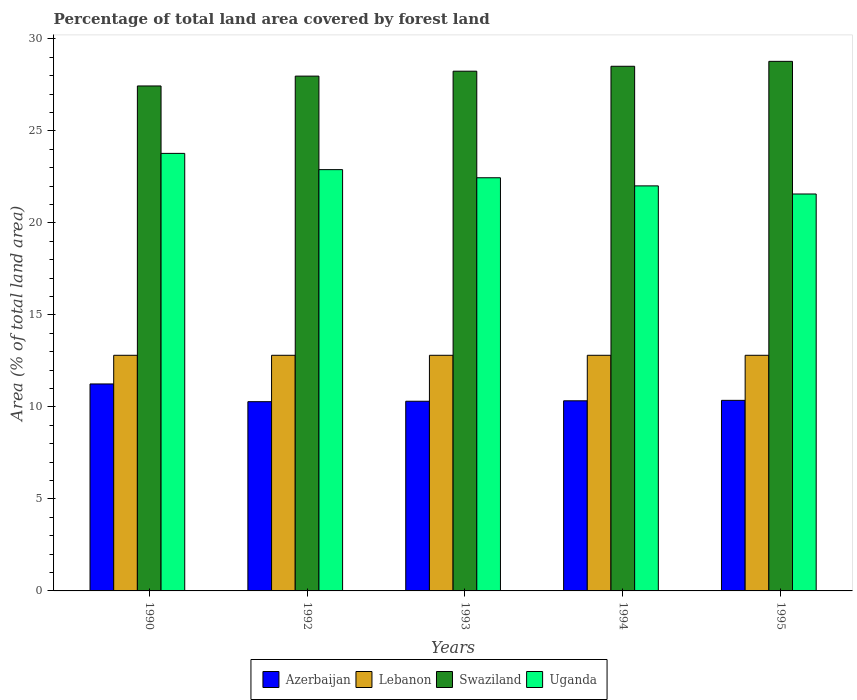Are the number of bars on each tick of the X-axis equal?
Offer a terse response. Yes. How many bars are there on the 2nd tick from the left?
Offer a terse response. 4. How many bars are there on the 2nd tick from the right?
Offer a terse response. 4. In how many cases, is the number of bars for a given year not equal to the number of legend labels?
Your answer should be very brief. 0. What is the percentage of forest land in Azerbaijan in 1993?
Offer a very short reply. 10.31. Across all years, what is the maximum percentage of forest land in Azerbaijan?
Ensure brevity in your answer.  11.25. Across all years, what is the minimum percentage of forest land in Azerbaijan?
Your answer should be very brief. 10.28. In which year was the percentage of forest land in Lebanon maximum?
Give a very brief answer. 1990. What is the total percentage of forest land in Azerbaijan in the graph?
Offer a terse response. 52.53. What is the difference between the percentage of forest land in Lebanon in 1994 and that in 1995?
Make the answer very short. 0. What is the difference between the percentage of forest land in Swaziland in 1992 and the percentage of forest land in Azerbaijan in 1995?
Your answer should be very brief. 17.62. What is the average percentage of forest land in Uganda per year?
Provide a short and direct response. 22.54. In the year 1993, what is the difference between the percentage of forest land in Uganda and percentage of forest land in Swaziland?
Offer a terse response. -5.79. What is the ratio of the percentage of forest land in Lebanon in 1992 to that in 1994?
Your response must be concise. 1. Is the difference between the percentage of forest land in Uganda in 1990 and 1993 greater than the difference between the percentage of forest land in Swaziland in 1990 and 1993?
Keep it short and to the point. Yes. What is the difference between the highest and the lowest percentage of forest land in Azerbaijan?
Provide a succinct answer. 0.96. Is the sum of the percentage of forest land in Uganda in 1990 and 1995 greater than the maximum percentage of forest land in Lebanon across all years?
Make the answer very short. Yes. What does the 2nd bar from the left in 1994 represents?
Provide a short and direct response. Lebanon. What does the 1st bar from the right in 1990 represents?
Provide a short and direct response. Uganda. How many bars are there?
Your answer should be very brief. 20. Are all the bars in the graph horizontal?
Offer a very short reply. No. How many legend labels are there?
Ensure brevity in your answer.  4. What is the title of the graph?
Ensure brevity in your answer.  Percentage of total land area covered by forest land. Does "Central Europe" appear as one of the legend labels in the graph?
Your answer should be compact. No. What is the label or title of the Y-axis?
Your answer should be compact. Area (% of total land area). What is the Area (% of total land area) in Azerbaijan in 1990?
Offer a terse response. 11.25. What is the Area (% of total land area) in Lebanon in 1990?
Keep it short and to the point. 12.81. What is the Area (% of total land area) in Swaziland in 1990?
Provide a short and direct response. 27.44. What is the Area (% of total land area) in Uganda in 1990?
Your answer should be compact. 23.78. What is the Area (% of total land area) in Azerbaijan in 1992?
Offer a terse response. 10.28. What is the Area (% of total land area) in Lebanon in 1992?
Provide a short and direct response. 12.81. What is the Area (% of total land area) of Swaziland in 1992?
Ensure brevity in your answer.  27.98. What is the Area (% of total land area) of Uganda in 1992?
Keep it short and to the point. 22.89. What is the Area (% of total land area) in Azerbaijan in 1993?
Provide a succinct answer. 10.31. What is the Area (% of total land area) in Lebanon in 1993?
Keep it short and to the point. 12.81. What is the Area (% of total land area) in Swaziland in 1993?
Give a very brief answer. 28.24. What is the Area (% of total land area) in Uganda in 1993?
Offer a very short reply. 22.45. What is the Area (% of total land area) of Azerbaijan in 1994?
Ensure brevity in your answer.  10.33. What is the Area (% of total land area) of Lebanon in 1994?
Your answer should be compact. 12.81. What is the Area (% of total land area) in Swaziland in 1994?
Provide a short and direct response. 28.51. What is the Area (% of total land area) in Uganda in 1994?
Give a very brief answer. 22.01. What is the Area (% of total land area) in Azerbaijan in 1995?
Offer a terse response. 10.36. What is the Area (% of total land area) in Lebanon in 1995?
Provide a succinct answer. 12.81. What is the Area (% of total land area) in Swaziland in 1995?
Offer a terse response. 28.78. What is the Area (% of total land area) in Uganda in 1995?
Give a very brief answer. 21.57. Across all years, what is the maximum Area (% of total land area) in Azerbaijan?
Keep it short and to the point. 11.25. Across all years, what is the maximum Area (% of total land area) of Lebanon?
Your response must be concise. 12.81. Across all years, what is the maximum Area (% of total land area) of Swaziland?
Provide a short and direct response. 28.78. Across all years, what is the maximum Area (% of total land area) of Uganda?
Keep it short and to the point. 23.78. Across all years, what is the minimum Area (% of total land area) of Azerbaijan?
Offer a terse response. 10.28. Across all years, what is the minimum Area (% of total land area) of Lebanon?
Your response must be concise. 12.81. Across all years, what is the minimum Area (% of total land area) of Swaziland?
Provide a succinct answer. 27.44. Across all years, what is the minimum Area (% of total land area) of Uganda?
Your answer should be compact. 21.57. What is the total Area (% of total land area) in Azerbaijan in the graph?
Your answer should be compact. 52.53. What is the total Area (% of total land area) of Lebanon in the graph?
Give a very brief answer. 64.03. What is the total Area (% of total land area) of Swaziland in the graph?
Keep it short and to the point. 140.95. What is the total Area (% of total land area) in Uganda in the graph?
Give a very brief answer. 112.71. What is the difference between the Area (% of total land area) in Azerbaijan in 1990 and that in 1992?
Offer a very short reply. 0.96. What is the difference between the Area (% of total land area) of Swaziland in 1990 and that in 1992?
Offer a terse response. -0.53. What is the difference between the Area (% of total land area) of Uganda in 1990 and that in 1992?
Provide a short and direct response. 0.88. What is the difference between the Area (% of total land area) of Azerbaijan in 1990 and that in 1993?
Ensure brevity in your answer.  0.94. What is the difference between the Area (% of total land area) in Lebanon in 1990 and that in 1993?
Offer a very short reply. 0. What is the difference between the Area (% of total land area) in Swaziland in 1990 and that in 1993?
Your answer should be compact. -0.8. What is the difference between the Area (% of total land area) of Uganda in 1990 and that in 1993?
Your answer should be very brief. 1.32. What is the difference between the Area (% of total land area) in Azerbaijan in 1990 and that in 1994?
Give a very brief answer. 0.92. What is the difference between the Area (% of total land area) in Swaziland in 1990 and that in 1994?
Your answer should be very brief. -1.07. What is the difference between the Area (% of total land area) in Uganda in 1990 and that in 1994?
Keep it short and to the point. 1.77. What is the difference between the Area (% of total land area) of Azerbaijan in 1990 and that in 1995?
Provide a succinct answer. 0.89. What is the difference between the Area (% of total land area) of Swaziland in 1990 and that in 1995?
Your answer should be compact. -1.34. What is the difference between the Area (% of total land area) of Uganda in 1990 and that in 1995?
Your answer should be compact. 2.21. What is the difference between the Area (% of total land area) in Azerbaijan in 1992 and that in 1993?
Give a very brief answer. -0.02. What is the difference between the Area (% of total land area) of Swaziland in 1992 and that in 1993?
Your response must be concise. -0.27. What is the difference between the Area (% of total land area) of Uganda in 1992 and that in 1993?
Offer a very short reply. 0.44. What is the difference between the Area (% of total land area) in Azerbaijan in 1992 and that in 1994?
Make the answer very short. -0.05. What is the difference between the Area (% of total land area) in Lebanon in 1992 and that in 1994?
Your answer should be very brief. 0. What is the difference between the Area (% of total land area) in Swaziland in 1992 and that in 1994?
Provide a short and direct response. -0.53. What is the difference between the Area (% of total land area) in Uganda in 1992 and that in 1994?
Offer a terse response. 0.88. What is the difference between the Area (% of total land area) of Azerbaijan in 1992 and that in 1995?
Provide a succinct answer. -0.07. What is the difference between the Area (% of total land area) of Swaziland in 1992 and that in 1995?
Ensure brevity in your answer.  -0.8. What is the difference between the Area (% of total land area) of Uganda in 1992 and that in 1995?
Provide a succinct answer. 1.32. What is the difference between the Area (% of total land area) in Azerbaijan in 1993 and that in 1994?
Keep it short and to the point. -0.02. What is the difference between the Area (% of total land area) of Swaziland in 1993 and that in 1994?
Make the answer very short. -0.27. What is the difference between the Area (% of total land area) in Uganda in 1993 and that in 1994?
Your answer should be compact. 0.44. What is the difference between the Area (% of total land area) of Azerbaijan in 1993 and that in 1995?
Provide a succinct answer. -0.05. What is the difference between the Area (% of total land area) of Lebanon in 1993 and that in 1995?
Your response must be concise. 0. What is the difference between the Area (% of total land area) of Swaziland in 1993 and that in 1995?
Offer a terse response. -0.53. What is the difference between the Area (% of total land area) of Uganda in 1993 and that in 1995?
Ensure brevity in your answer.  0.88. What is the difference between the Area (% of total land area) in Azerbaijan in 1994 and that in 1995?
Offer a very short reply. -0.02. What is the difference between the Area (% of total land area) of Swaziland in 1994 and that in 1995?
Offer a very short reply. -0.27. What is the difference between the Area (% of total land area) in Uganda in 1994 and that in 1995?
Make the answer very short. 0.44. What is the difference between the Area (% of total land area) in Azerbaijan in 1990 and the Area (% of total land area) in Lebanon in 1992?
Give a very brief answer. -1.56. What is the difference between the Area (% of total land area) of Azerbaijan in 1990 and the Area (% of total land area) of Swaziland in 1992?
Ensure brevity in your answer.  -16.73. What is the difference between the Area (% of total land area) in Azerbaijan in 1990 and the Area (% of total land area) in Uganda in 1992?
Offer a very short reply. -11.65. What is the difference between the Area (% of total land area) in Lebanon in 1990 and the Area (% of total land area) in Swaziland in 1992?
Provide a short and direct response. -15.17. What is the difference between the Area (% of total land area) of Lebanon in 1990 and the Area (% of total land area) of Uganda in 1992?
Offer a very short reply. -10.09. What is the difference between the Area (% of total land area) of Swaziland in 1990 and the Area (% of total land area) of Uganda in 1992?
Make the answer very short. 4.55. What is the difference between the Area (% of total land area) in Azerbaijan in 1990 and the Area (% of total land area) in Lebanon in 1993?
Make the answer very short. -1.56. What is the difference between the Area (% of total land area) in Azerbaijan in 1990 and the Area (% of total land area) in Swaziland in 1993?
Your answer should be very brief. -17. What is the difference between the Area (% of total land area) in Azerbaijan in 1990 and the Area (% of total land area) in Uganda in 1993?
Offer a very short reply. -11.21. What is the difference between the Area (% of total land area) of Lebanon in 1990 and the Area (% of total land area) of Swaziland in 1993?
Offer a very short reply. -15.44. What is the difference between the Area (% of total land area) in Lebanon in 1990 and the Area (% of total land area) in Uganda in 1993?
Offer a very short reply. -9.65. What is the difference between the Area (% of total land area) of Swaziland in 1990 and the Area (% of total land area) of Uganda in 1993?
Give a very brief answer. 4.99. What is the difference between the Area (% of total land area) in Azerbaijan in 1990 and the Area (% of total land area) in Lebanon in 1994?
Make the answer very short. -1.56. What is the difference between the Area (% of total land area) in Azerbaijan in 1990 and the Area (% of total land area) in Swaziland in 1994?
Ensure brevity in your answer.  -17.26. What is the difference between the Area (% of total land area) of Azerbaijan in 1990 and the Area (% of total land area) of Uganda in 1994?
Offer a very short reply. -10.76. What is the difference between the Area (% of total land area) of Lebanon in 1990 and the Area (% of total land area) of Swaziland in 1994?
Your answer should be very brief. -15.71. What is the difference between the Area (% of total land area) of Lebanon in 1990 and the Area (% of total land area) of Uganda in 1994?
Offer a terse response. -9.21. What is the difference between the Area (% of total land area) in Swaziland in 1990 and the Area (% of total land area) in Uganda in 1994?
Provide a short and direct response. 5.43. What is the difference between the Area (% of total land area) of Azerbaijan in 1990 and the Area (% of total land area) of Lebanon in 1995?
Offer a terse response. -1.56. What is the difference between the Area (% of total land area) of Azerbaijan in 1990 and the Area (% of total land area) of Swaziland in 1995?
Give a very brief answer. -17.53. What is the difference between the Area (% of total land area) of Azerbaijan in 1990 and the Area (% of total land area) of Uganda in 1995?
Offer a very short reply. -10.32. What is the difference between the Area (% of total land area) of Lebanon in 1990 and the Area (% of total land area) of Swaziland in 1995?
Give a very brief answer. -15.97. What is the difference between the Area (% of total land area) of Lebanon in 1990 and the Area (% of total land area) of Uganda in 1995?
Give a very brief answer. -8.77. What is the difference between the Area (% of total land area) of Swaziland in 1990 and the Area (% of total land area) of Uganda in 1995?
Give a very brief answer. 5.87. What is the difference between the Area (% of total land area) in Azerbaijan in 1992 and the Area (% of total land area) in Lebanon in 1993?
Make the answer very short. -2.52. What is the difference between the Area (% of total land area) of Azerbaijan in 1992 and the Area (% of total land area) of Swaziland in 1993?
Offer a terse response. -17.96. What is the difference between the Area (% of total land area) in Azerbaijan in 1992 and the Area (% of total land area) in Uganda in 1993?
Provide a succinct answer. -12.17. What is the difference between the Area (% of total land area) in Lebanon in 1992 and the Area (% of total land area) in Swaziland in 1993?
Your answer should be compact. -15.44. What is the difference between the Area (% of total land area) in Lebanon in 1992 and the Area (% of total land area) in Uganda in 1993?
Offer a terse response. -9.65. What is the difference between the Area (% of total land area) of Swaziland in 1992 and the Area (% of total land area) of Uganda in 1993?
Make the answer very short. 5.52. What is the difference between the Area (% of total land area) in Azerbaijan in 1992 and the Area (% of total land area) in Lebanon in 1994?
Give a very brief answer. -2.52. What is the difference between the Area (% of total land area) in Azerbaijan in 1992 and the Area (% of total land area) in Swaziland in 1994?
Offer a terse response. -18.23. What is the difference between the Area (% of total land area) of Azerbaijan in 1992 and the Area (% of total land area) of Uganda in 1994?
Provide a short and direct response. -11.73. What is the difference between the Area (% of total land area) of Lebanon in 1992 and the Area (% of total land area) of Swaziland in 1994?
Give a very brief answer. -15.71. What is the difference between the Area (% of total land area) in Lebanon in 1992 and the Area (% of total land area) in Uganda in 1994?
Ensure brevity in your answer.  -9.21. What is the difference between the Area (% of total land area) in Swaziland in 1992 and the Area (% of total land area) in Uganda in 1994?
Give a very brief answer. 5.96. What is the difference between the Area (% of total land area) in Azerbaijan in 1992 and the Area (% of total land area) in Lebanon in 1995?
Give a very brief answer. -2.52. What is the difference between the Area (% of total land area) of Azerbaijan in 1992 and the Area (% of total land area) of Swaziland in 1995?
Your response must be concise. -18.5. What is the difference between the Area (% of total land area) in Azerbaijan in 1992 and the Area (% of total land area) in Uganda in 1995?
Offer a very short reply. -11.29. What is the difference between the Area (% of total land area) of Lebanon in 1992 and the Area (% of total land area) of Swaziland in 1995?
Give a very brief answer. -15.97. What is the difference between the Area (% of total land area) of Lebanon in 1992 and the Area (% of total land area) of Uganda in 1995?
Make the answer very short. -8.77. What is the difference between the Area (% of total land area) in Swaziland in 1992 and the Area (% of total land area) in Uganda in 1995?
Make the answer very short. 6.41. What is the difference between the Area (% of total land area) in Azerbaijan in 1993 and the Area (% of total land area) in Lebanon in 1994?
Make the answer very short. -2.5. What is the difference between the Area (% of total land area) in Azerbaijan in 1993 and the Area (% of total land area) in Swaziland in 1994?
Your answer should be very brief. -18.2. What is the difference between the Area (% of total land area) in Azerbaijan in 1993 and the Area (% of total land area) in Uganda in 1994?
Keep it short and to the point. -11.7. What is the difference between the Area (% of total land area) of Lebanon in 1993 and the Area (% of total land area) of Swaziland in 1994?
Your answer should be compact. -15.71. What is the difference between the Area (% of total land area) of Lebanon in 1993 and the Area (% of total land area) of Uganda in 1994?
Your answer should be very brief. -9.21. What is the difference between the Area (% of total land area) of Swaziland in 1993 and the Area (% of total land area) of Uganda in 1994?
Your response must be concise. 6.23. What is the difference between the Area (% of total land area) in Azerbaijan in 1993 and the Area (% of total land area) in Lebanon in 1995?
Give a very brief answer. -2.5. What is the difference between the Area (% of total land area) in Azerbaijan in 1993 and the Area (% of total land area) in Swaziland in 1995?
Ensure brevity in your answer.  -18.47. What is the difference between the Area (% of total land area) in Azerbaijan in 1993 and the Area (% of total land area) in Uganda in 1995?
Your response must be concise. -11.26. What is the difference between the Area (% of total land area) of Lebanon in 1993 and the Area (% of total land area) of Swaziland in 1995?
Keep it short and to the point. -15.97. What is the difference between the Area (% of total land area) of Lebanon in 1993 and the Area (% of total land area) of Uganda in 1995?
Offer a very short reply. -8.77. What is the difference between the Area (% of total land area) of Swaziland in 1993 and the Area (% of total land area) of Uganda in 1995?
Give a very brief answer. 6.67. What is the difference between the Area (% of total land area) of Azerbaijan in 1994 and the Area (% of total land area) of Lebanon in 1995?
Provide a succinct answer. -2.47. What is the difference between the Area (% of total land area) of Azerbaijan in 1994 and the Area (% of total land area) of Swaziland in 1995?
Provide a succinct answer. -18.45. What is the difference between the Area (% of total land area) of Azerbaijan in 1994 and the Area (% of total land area) of Uganda in 1995?
Give a very brief answer. -11.24. What is the difference between the Area (% of total land area) in Lebanon in 1994 and the Area (% of total land area) in Swaziland in 1995?
Offer a very short reply. -15.97. What is the difference between the Area (% of total land area) in Lebanon in 1994 and the Area (% of total land area) in Uganda in 1995?
Ensure brevity in your answer.  -8.77. What is the difference between the Area (% of total land area) in Swaziland in 1994 and the Area (% of total land area) in Uganda in 1995?
Offer a terse response. 6.94. What is the average Area (% of total land area) in Azerbaijan per year?
Offer a terse response. 10.51. What is the average Area (% of total land area) in Lebanon per year?
Keep it short and to the point. 12.81. What is the average Area (% of total land area) in Swaziland per year?
Keep it short and to the point. 28.19. What is the average Area (% of total land area) of Uganda per year?
Your answer should be very brief. 22.54. In the year 1990, what is the difference between the Area (% of total land area) of Azerbaijan and Area (% of total land area) of Lebanon?
Offer a terse response. -1.56. In the year 1990, what is the difference between the Area (% of total land area) in Azerbaijan and Area (% of total land area) in Swaziland?
Provide a succinct answer. -16.19. In the year 1990, what is the difference between the Area (% of total land area) in Azerbaijan and Area (% of total land area) in Uganda?
Provide a succinct answer. -12.53. In the year 1990, what is the difference between the Area (% of total land area) of Lebanon and Area (% of total land area) of Swaziland?
Your answer should be very brief. -14.64. In the year 1990, what is the difference between the Area (% of total land area) in Lebanon and Area (% of total land area) in Uganda?
Your response must be concise. -10.97. In the year 1990, what is the difference between the Area (% of total land area) in Swaziland and Area (% of total land area) in Uganda?
Your response must be concise. 3.66. In the year 1992, what is the difference between the Area (% of total land area) of Azerbaijan and Area (% of total land area) of Lebanon?
Offer a terse response. -2.52. In the year 1992, what is the difference between the Area (% of total land area) of Azerbaijan and Area (% of total land area) of Swaziland?
Provide a succinct answer. -17.69. In the year 1992, what is the difference between the Area (% of total land area) in Azerbaijan and Area (% of total land area) in Uganda?
Your answer should be compact. -12.61. In the year 1992, what is the difference between the Area (% of total land area) in Lebanon and Area (% of total land area) in Swaziland?
Provide a succinct answer. -15.17. In the year 1992, what is the difference between the Area (% of total land area) of Lebanon and Area (% of total land area) of Uganda?
Give a very brief answer. -10.09. In the year 1992, what is the difference between the Area (% of total land area) of Swaziland and Area (% of total land area) of Uganda?
Provide a succinct answer. 5.08. In the year 1993, what is the difference between the Area (% of total land area) in Azerbaijan and Area (% of total land area) in Lebanon?
Provide a short and direct response. -2.5. In the year 1993, what is the difference between the Area (% of total land area) of Azerbaijan and Area (% of total land area) of Swaziland?
Your response must be concise. -17.94. In the year 1993, what is the difference between the Area (% of total land area) of Azerbaijan and Area (% of total land area) of Uganda?
Ensure brevity in your answer.  -12.15. In the year 1993, what is the difference between the Area (% of total land area) of Lebanon and Area (% of total land area) of Swaziland?
Offer a very short reply. -15.44. In the year 1993, what is the difference between the Area (% of total land area) in Lebanon and Area (% of total land area) in Uganda?
Your response must be concise. -9.65. In the year 1993, what is the difference between the Area (% of total land area) of Swaziland and Area (% of total land area) of Uganda?
Give a very brief answer. 5.79. In the year 1994, what is the difference between the Area (% of total land area) in Azerbaijan and Area (% of total land area) in Lebanon?
Your answer should be very brief. -2.47. In the year 1994, what is the difference between the Area (% of total land area) of Azerbaijan and Area (% of total land area) of Swaziland?
Ensure brevity in your answer.  -18.18. In the year 1994, what is the difference between the Area (% of total land area) in Azerbaijan and Area (% of total land area) in Uganda?
Keep it short and to the point. -11.68. In the year 1994, what is the difference between the Area (% of total land area) in Lebanon and Area (% of total land area) in Swaziland?
Your answer should be very brief. -15.71. In the year 1994, what is the difference between the Area (% of total land area) in Lebanon and Area (% of total land area) in Uganda?
Your answer should be very brief. -9.21. In the year 1994, what is the difference between the Area (% of total land area) in Swaziland and Area (% of total land area) in Uganda?
Your answer should be compact. 6.5. In the year 1995, what is the difference between the Area (% of total land area) of Azerbaijan and Area (% of total land area) of Lebanon?
Keep it short and to the point. -2.45. In the year 1995, what is the difference between the Area (% of total land area) in Azerbaijan and Area (% of total land area) in Swaziland?
Your response must be concise. -18.42. In the year 1995, what is the difference between the Area (% of total land area) in Azerbaijan and Area (% of total land area) in Uganda?
Make the answer very short. -11.21. In the year 1995, what is the difference between the Area (% of total land area) in Lebanon and Area (% of total land area) in Swaziland?
Your answer should be very brief. -15.97. In the year 1995, what is the difference between the Area (% of total land area) of Lebanon and Area (% of total land area) of Uganda?
Give a very brief answer. -8.77. In the year 1995, what is the difference between the Area (% of total land area) in Swaziland and Area (% of total land area) in Uganda?
Offer a terse response. 7.21. What is the ratio of the Area (% of total land area) in Azerbaijan in 1990 to that in 1992?
Your response must be concise. 1.09. What is the ratio of the Area (% of total land area) in Swaziland in 1990 to that in 1992?
Provide a short and direct response. 0.98. What is the ratio of the Area (% of total land area) of Uganda in 1990 to that in 1992?
Give a very brief answer. 1.04. What is the ratio of the Area (% of total land area) in Azerbaijan in 1990 to that in 1993?
Your response must be concise. 1.09. What is the ratio of the Area (% of total land area) in Lebanon in 1990 to that in 1993?
Provide a succinct answer. 1. What is the ratio of the Area (% of total land area) of Swaziland in 1990 to that in 1993?
Your answer should be compact. 0.97. What is the ratio of the Area (% of total land area) of Uganda in 1990 to that in 1993?
Provide a succinct answer. 1.06. What is the ratio of the Area (% of total land area) in Azerbaijan in 1990 to that in 1994?
Provide a succinct answer. 1.09. What is the ratio of the Area (% of total land area) in Swaziland in 1990 to that in 1994?
Give a very brief answer. 0.96. What is the ratio of the Area (% of total land area) in Uganda in 1990 to that in 1994?
Give a very brief answer. 1.08. What is the ratio of the Area (% of total land area) of Azerbaijan in 1990 to that in 1995?
Provide a short and direct response. 1.09. What is the ratio of the Area (% of total land area) in Swaziland in 1990 to that in 1995?
Keep it short and to the point. 0.95. What is the ratio of the Area (% of total land area) of Uganda in 1990 to that in 1995?
Your answer should be very brief. 1.1. What is the ratio of the Area (% of total land area) of Azerbaijan in 1992 to that in 1993?
Your answer should be very brief. 1. What is the ratio of the Area (% of total land area) in Uganda in 1992 to that in 1993?
Provide a succinct answer. 1.02. What is the ratio of the Area (% of total land area) of Azerbaijan in 1992 to that in 1994?
Offer a terse response. 1. What is the ratio of the Area (% of total land area) in Swaziland in 1992 to that in 1994?
Give a very brief answer. 0.98. What is the ratio of the Area (% of total land area) in Uganda in 1992 to that in 1994?
Provide a succinct answer. 1.04. What is the ratio of the Area (% of total land area) in Azerbaijan in 1992 to that in 1995?
Provide a succinct answer. 0.99. What is the ratio of the Area (% of total land area) of Swaziland in 1992 to that in 1995?
Your answer should be compact. 0.97. What is the ratio of the Area (% of total land area) of Uganda in 1992 to that in 1995?
Offer a very short reply. 1.06. What is the ratio of the Area (% of total land area) of Lebanon in 1993 to that in 1994?
Your response must be concise. 1. What is the ratio of the Area (% of total land area) in Swaziland in 1993 to that in 1994?
Your answer should be compact. 0.99. What is the ratio of the Area (% of total land area) of Uganda in 1993 to that in 1994?
Give a very brief answer. 1.02. What is the ratio of the Area (% of total land area) of Lebanon in 1993 to that in 1995?
Your answer should be very brief. 1. What is the ratio of the Area (% of total land area) in Swaziland in 1993 to that in 1995?
Provide a succinct answer. 0.98. What is the ratio of the Area (% of total land area) in Uganda in 1993 to that in 1995?
Keep it short and to the point. 1.04. What is the ratio of the Area (% of total land area) in Swaziland in 1994 to that in 1995?
Make the answer very short. 0.99. What is the ratio of the Area (% of total land area) of Uganda in 1994 to that in 1995?
Your response must be concise. 1.02. What is the difference between the highest and the second highest Area (% of total land area) of Azerbaijan?
Ensure brevity in your answer.  0.89. What is the difference between the highest and the second highest Area (% of total land area) of Swaziland?
Your answer should be compact. 0.27. What is the difference between the highest and the second highest Area (% of total land area) of Uganda?
Keep it short and to the point. 0.88. What is the difference between the highest and the lowest Area (% of total land area) of Azerbaijan?
Your response must be concise. 0.96. What is the difference between the highest and the lowest Area (% of total land area) of Lebanon?
Your answer should be compact. 0. What is the difference between the highest and the lowest Area (% of total land area) of Swaziland?
Offer a very short reply. 1.34. What is the difference between the highest and the lowest Area (% of total land area) of Uganda?
Ensure brevity in your answer.  2.21. 